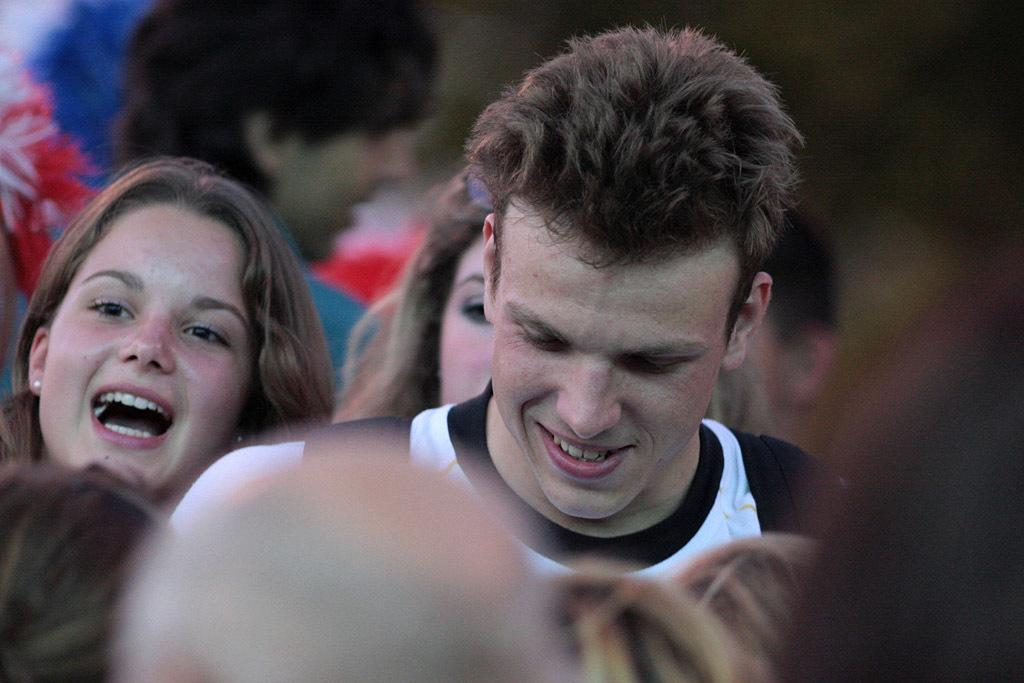Who is present in the image? There is a man and a woman in the image. What expressions do the man and woman have in the image? The man and woman are both smiling in the image. Are there any other people visible in the surroundings? Yes, there are people visible in the surroundings. What time of day does the church service take place in the image? There is no church or service depicted in the image, so it is not possible to determine the time of day. 